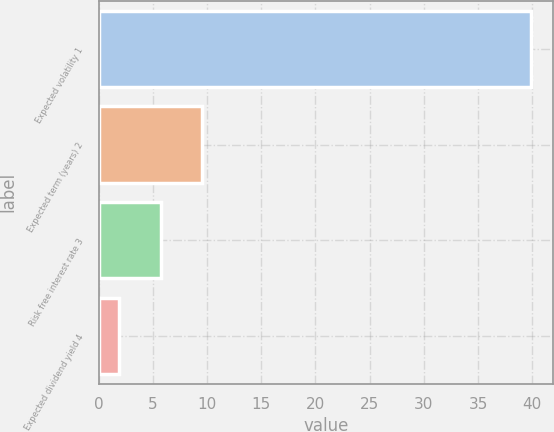Convert chart to OTSL. <chart><loc_0><loc_0><loc_500><loc_500><bar_chart><fcel>Expected volatility 1<fcel>Expected term (years) 2<fcel>Risk free interest rate 3<fcel>Expected dividend yield 4<nl><fcel>39.9<fcel>9.5<fcel>5.7<fcel>1.9<nl></chart> 